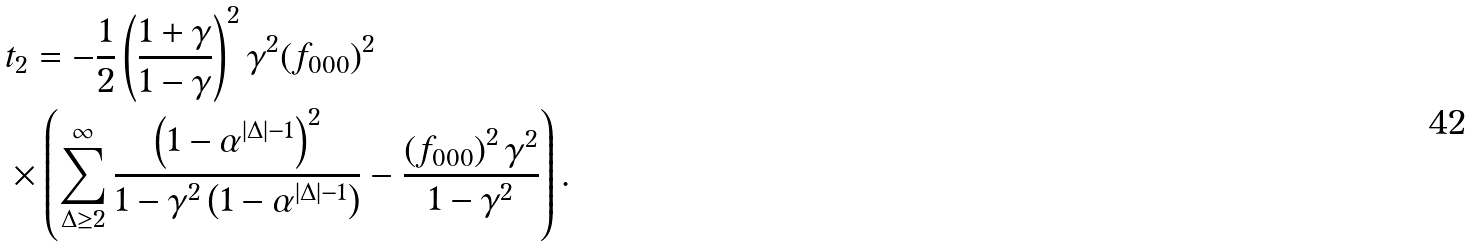<formula> <loc_0><loc_0><loc_500><loc_500>& t _ { 2 } = - \frac { 1 } { 2 } \left ( \frac { 1 + \gamma } { 1 - \gamma } \right ) ^ { 2 } \gamma ^ { 2 } ( f _ { 0 0 0 } ) ^ { 2 } \\ & \times \left ( \sum _ { \Delta \geq 2 } ^ { \infty } \frac { \left ( 1 - \alpha ^ { | \Delta | - 1 } \right ) ^ { 2 } } { 1 - \gamma ^ { 2 } \left ( 1 - \alpha ^ { | \Delta | - 1 } \right ) } - \frac { \left ( f _ { 0 0 0 } \right ) ^ { 2 } \gamma ^ { 2 } } { 1 - \gamma ^ { 2 } } \right ) .</formula> 